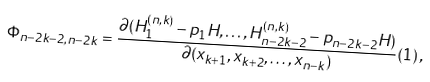<formula> <loc_0><loc_0><loc_500><loc_500>\Phi _ { n - 2 k - 2 , n - 2 k } = \frac { \partial ( H _ { 1 } ^ { ( n , k ) } - p _ { 1 } H , \dots , H _ { n - 2 k - 2 } ^ { ( n , k ) } - p _ { n - 2 k - 2 } H ) } { \partial ( x _ { k + 1 } , x _ { k + 2 } , \dots , x _ { n - k } ) } ( { 1 } ) \, ,</formula> 